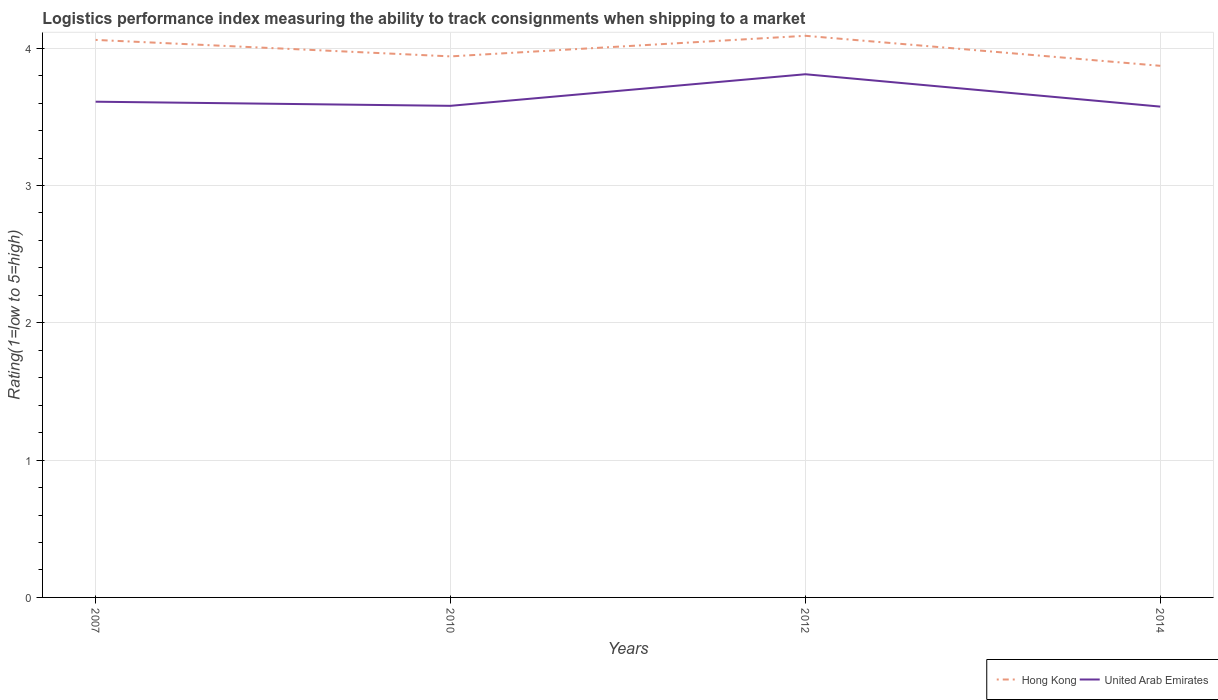How many different coloured lines are there?
Keep it short and to the point. 2. Does the line corresponding to Hong Kong intersect with the line corresponding to United Arab Emirates?
Give a very brief answer. No. Is the number of lines equal to the number of legend labels?
Your answer should be very brief. Yes. Across all years, what is the maximum Logistic performance index in Hong Kong?
Keep it short and to the point. 3.87. What is the total Logistic performance index in Hong Kong in the graph?
Ensure brevity in your answer.  0.12. What is the difference between the highest and the second highest Logistic performance index in Hong Kong?
Make the answer very short. 0.22. What is the difference between the highest and the lowest Logistic performance index in Hong Kong?
Make the answer very short. 2. Where does the legend appear in the graph?
Provide a succinct answer. Bottom right. What is the title of the graph?
Ensure brevity in your answer.  Logistics performance index measuring the ability to track consignments when shipping to a market. What is the label or title of the Y-axis?
Your answer should be very brief. Rating(1=low to 5=high). What is the Rating(1=low to 5=high) in Hong Kong in 2007?
Your response must be concise. 4.06. What is the Rating(1=low to 5=high) of United Arab Emirates in 2007?
Your answer should be compact. 3.61. What is the Rating(1=low to 5=high) of Hong Kong in 2010?
Give a very brief answer. 3.94. What is the Rating(1=low to 5=high) in United Arab Emirates in 2010?
Your response must be concise. 3.58. What is the Rating(1=low to 5=high) of Hong Kong in 2012?
Offer a terse response. 4.09. What is the Rating(1=low to 5=high) in United Arab Emirates in 2012?
Offer a terse response. 3.81. What is the Rating(1=low to 5=high) in Hong Kong in 2014?
Provide a short and direct response. 3.87. What is the Rating(1=low to 5=high) of United Arab Emirates in 2014?
Make the answer very short. 3.57. Across all years, what is the maximum Rating(1=low to 5=high) of Hong Kong?
Give a very brief answer. 4.09. Across all years, what is the maximum Rating(1=low to 5=high) of United Arab Emirates?
Give a very brief answer. 3.81. Across all years, what is the minimum Rating(1=low to 5=high) of Hong Kong?
Your answer should be very brief. 3.87. Across all years, what is the minimum Rating(1=low to 5=high) in United Arab Emirates?
Ensure brevity in your answer.  3.57. What is the total Rating(1=low to 5=high) of Hong Kong in the graph?
Offer a very short reply. 15.96. What is the total Rating(1=low to 5=high) in United Arab Emirates in the graph?
Make the answer very short. 14.57. What is the difference between the Rating(1=low to 5=high) of Hong Kong in 2007 and that in 2010?
Give a very brief answer. 0.12. What is the difference between the Rating(1=low to 5=high) in Hong Kong in 2007 and that in 2012?
Offer a very short reply. -0.03. What is the difference between the Rating(1=low to 5=high) of Hong Kong in 2007 and that in 2014?
Make the answer very short. 0.19. What is the difference between the Rating(1=low to 5=high) in United Arab Emirates in 2007 and that in 2014?
Ensure brevity in your answer.  0.04. What is the difference between the Rating(1=low to 5=high) of United Arab Emirates in 2010 and that in 2012?
Your response must be concise. -0.23. What is the difference between the Rating(1=low to 5=high) of Hong Kong in 2010 and that in 2014?
Offer a terse response. 0.07. What is the difference between the Rating(1=low to 5=high) in United Arab Emirates in 2010 and that in 2014?
Provide a succinct answer. 0.01. What is the difference between the Rating(1=low to 5=high) of Hong Kong in 2012 and that in 2014?
Ensure brevity in your answer.  0.22. What is the difference between the Rating(1=low to 5=high) of United Arab Emirates in 2012 and that in 2014?
Provide a short and direct response. 0.24. What is the difference between the Rating(1=low to 5=high) in Hong Kong in 2007 and the Rating(1=low to 5=high) in United Arab Emirates in 2010?
Your response must be concise. 0.48. What is the difference between the Rating(1=low to 5=high) of Hong Kong in 2007 and the Rating(1=low to 5=high) of United Arab Emirates in 2012?
Make the answer very short. 0.25. What is the difference between the Rating(1=low to 5=high) in Hong Kong in 2007 and the Rating(1=low to 5=high) in United Arab Emirates in 2014?
Give a very brief answer. 0.49. What is the difference between the Rating(1=low to 5=high) of Hong Kong in 2010 and the Rating(1=low to 5=high) of United Arab Emirates in 2012?
Give a very brief answer. 0.13. What is the difference between the Rating(1=low to 5=high) of Hong Kong in 2010 and the Rating(1=low to 5=high) of United Arab Emirates in 2014?
Give a very brief answer. 0.37. What is the difference between the Rating(1=low to 5=high) of Hong Kong in 2012 and the Rating(1=low to 5=high) of United Arab Emirates in 2014?
Keep it short and to the point. 0.52. What is the average Rating(1=low to 5=high) of Hong Kong per year?
Your response must be concise. 3.99. What is the average Rating(1=low to 5=high) of United Arab Emirates per year?
Your response must be concise. 3.64. In the year 2007, what is the difference between the Rating(1=low to 5=high) of Hong Kong and Rating(1=low to 5=high) of United Arab Emirates?
Provide a succinct answer. 0.45. In the year 2010, what is the difference between the Rating(1=low to 5=high) of Hong Kong and Rating(1=low to 5=high) of United Arab Emirates?
Your answer should be very brief. 0.36. In the year 2012, what is the difference between the Rating(1=low to 5=high) in Hong Kong and Rating(1=low to 5=high) in United Arab Emirates?
Offer a terse response. 0.28. In the year 2014, what is the difference between the Rating(1=low to 5=high) in Hong Kong and Rating(1=low to 5=high) in United Arab Emirates?
Make the answer very short. 0.3. What is the ratio of the Rating(1=low to 5=high) of Hong Kong in 2007 to that in 2010?
Offer a very short reply. 1.03. What is the ratio of the Rating(1=low to 5=high) in United Arab Emirates in 2007 to that in 2010?
Your answer should be very brief. 1.01. What is the ratio of the Rating(1=low to 5=high) of Hong Kong in 2007 to that in 2012?
Provide a succinct answer. 0.99. What is the ratio of the Rating(1=low to 5=high) of United Arab Emirates in 2007 to that in 2012?
Make the answer very short. 0.95. What is the ratio of the Rating(1=low to 5=high) in Hong Kong in 2007 to that in 2014?
Give a very brief answer. 1.05. What is the ratio of the Rating(1=low to 5=high) of Hong Kong in 2010 to that in 2012?
Make the answer very short. 0.96. What is the ratio of the Rating(1=low to 5=high) in United Arab Emirates in 2010 to that in 2012?
Your answer should be very brief. 0.94. What is the ratio of the Rating(1=low to 5=high) of Hong Kong in 2010 to that in 2014?
Provide a succinct answer. 1.02. What is the ratio of the Rating(1=low to 5=high) in Hong Kong in 2012 to that in 2014?
Make the answer very short. 1.06. What is the ratio of the Rating(1=low to 5=high) in United Arab Emirates in 2012 to that in 2014?
Ensure brevity in your answer.  1.07. What is the difference between the highest and the second highest Rating(1=low to 5=high) in Hong Kong?
Give a very brief answer. 0.03. What is the difference between the highest and the lowest Rating(1=low to 5=high) of Hong Kong?
Keep it short and to the point. 0.22. What is the difference between the highest and the lowest Rating(1=low to 5=high) of United Arab Emirates?
Your response must be concise. 0.24. 